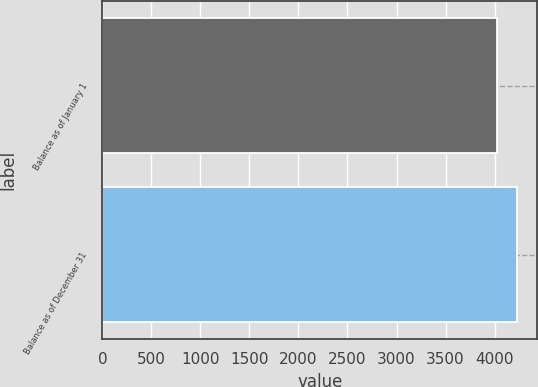Convert chart to OTSL. <chart><loc_0><loc_0><loc_500><loc_500><bar_chart><fcel>Balance as of January 1<fcel>Balance as of December 31<nl><fcel>4029<fcel>4224<nl></chart> 